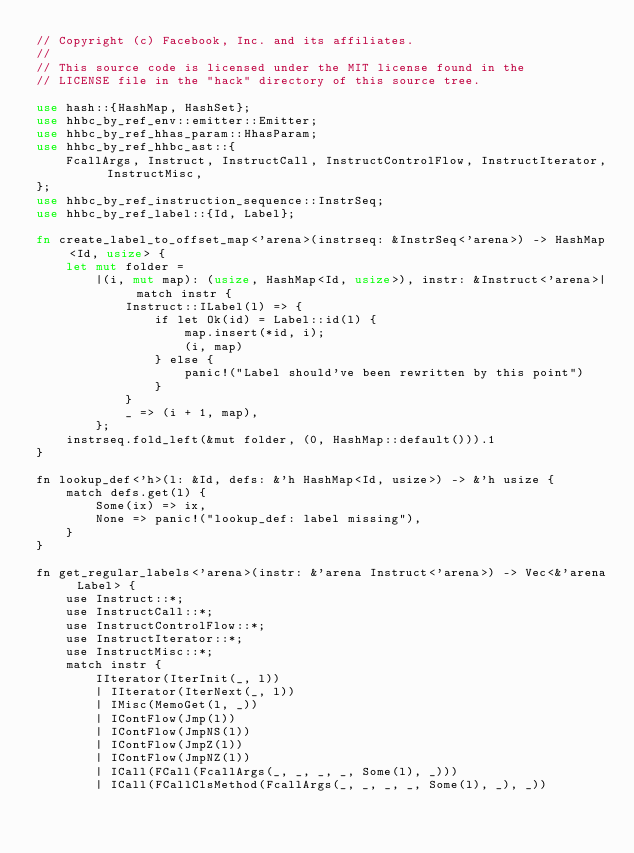Convert code to text. <code><loc_0><loc_0><loc_500><loc_500><_Rust_>// Copyright (c) Facebook, Inc. and its affiliates.
//
// This source code is licensed under the MIT license found in the
// LICENSE file in the "hack" directory of this source tree.

use hash::{HashMap, HashSet};
use hhbc_by_ref_env::emitter::Emitter;
use hhbc_by_ref_hhas_param::HhasParam;
use hhbc_by_ref_hhbc_ast::{
    FcallArgs, Instruct, InstructCall, InstructControlFlow, InstructIterator, InstructMisc,
};
use hhbc_by_ref_instruction_sequence::InstrSeq;
use hhbc_by_ref_label::{Id, Label};

fn create_label_to_offset_map<'arena>(instrseq: &InstrSeq<'arena>) -> HashMap<Id, usize> {
    let mut folder =
        |(i, mut map): (usize, HashMap<Id, usize>), instr: &Instruct<'arena>| match instr {
            Instruct::ILabel(l) => {
                if let Ok(id) = Label::id(l) {
                    map.insert(*id, i);
                    (i, map)
                } else {
                    panic!("Label should've been rewritten by this point")
                }
            }
            _ => (i + 1, map),
        };
    instrseq.fold_left(&mut folder, (0, HashMap::default())).1
}

fn lookup_def<'h>(l: &Id, defs: &'h HashMap<Id, usize>) -> &'h usize {
    match defs.get(l) {
        Some(ix) => ix,
        None => panic!("lookup_def: label missing"),
    }
}

fn get_regular_labels<'arena>(instr: &'arena Instruct<'arena>) -> Vec<&'arena Label> {
    use Instruct::*;
    use InstructCall::*;
    use InstructControlFlow::*;
    use InstructIterator::*;
    use InstructMisc::*;
    match instr {
        IIterator(IterInit(_, l))
        | IIterator(IterNext(_, l))
        | IMisc(MemoGet(l, _))
        | IContFlow(Jmp(l))
        | IContFlow(JmpNS(l))
        | IContFlow(JmpZ(l))
        | IContFlow(JmpNZ(l))
        | ICall(FCall(FcallArgs(_, _, _, _, Some(l), _)))
        | ICall(FCallClsMethod(FcallArgs(_, _, _, _, Some(l), _), _))</code> 